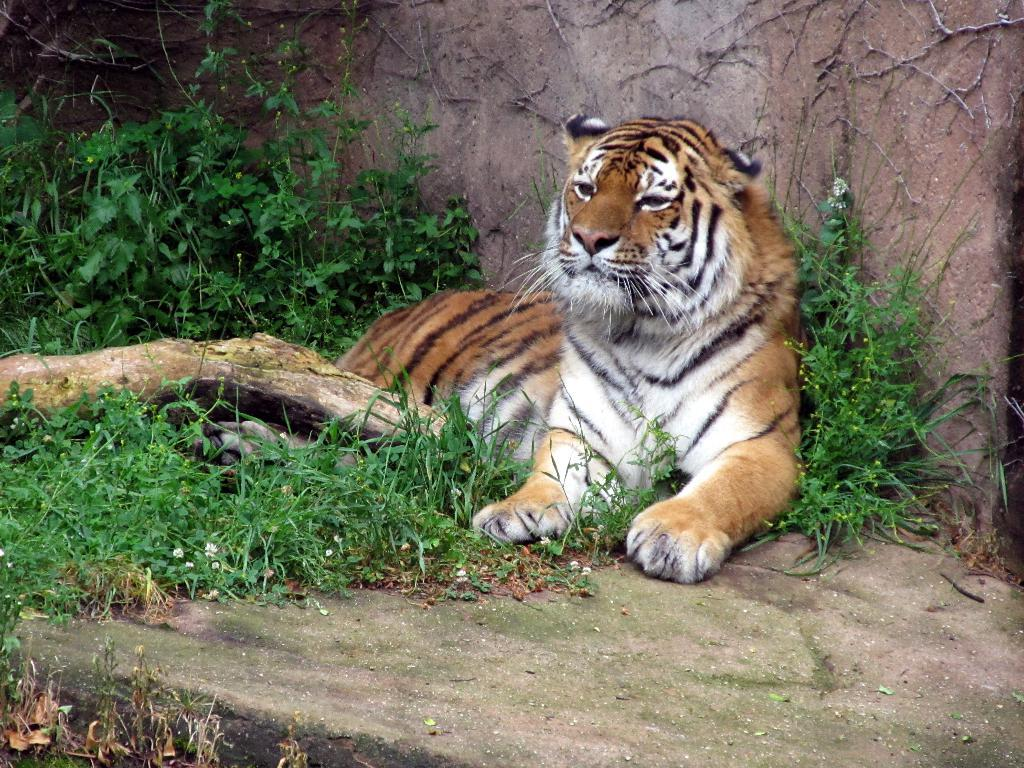What animal is the main subject of the image? There is a tiger in the image. What type of environment is the tiger in? There is green grass beside the tiger. What other object is near the tiger? There is a log beside the tiger. What can be seen in the background of the image? There is a wall in the background. What type of tooth can be seen in the image? There is no tooth present in the image; it features a tiger in a natural environment. 